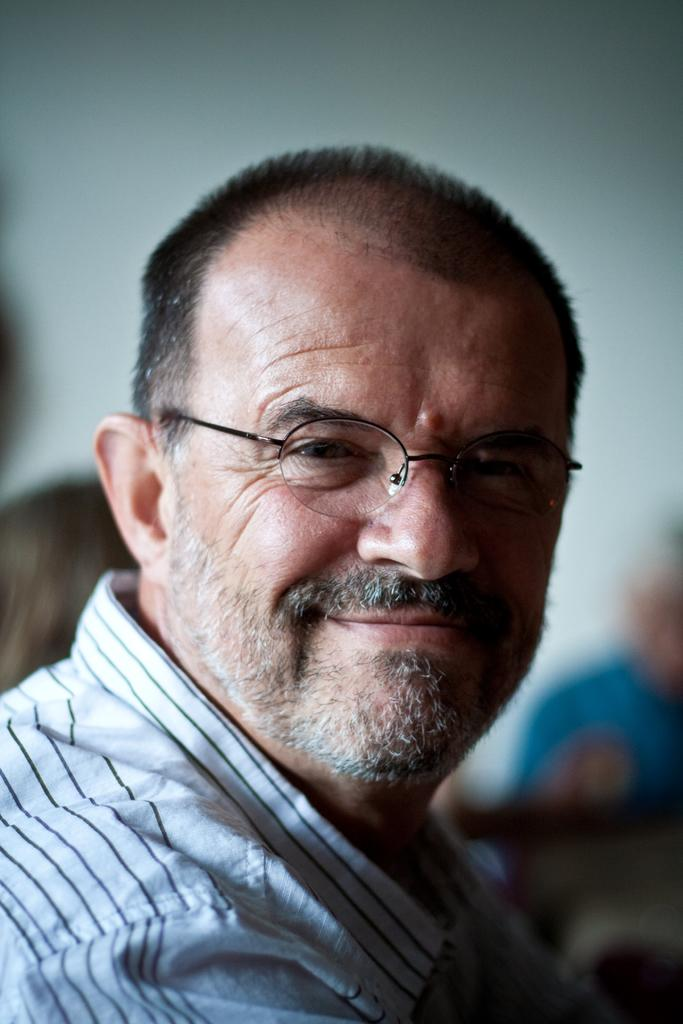What can be seen in the image? There is a person in the image. Can you describe the person's appearance? The person is wearing glasses. What is the background of the image like? The background of the image is blurry. What type of sofa is visible in the image? There is no sofa present in the image. What substance is the person holding in the image? The image does not show the person holding any substance. 